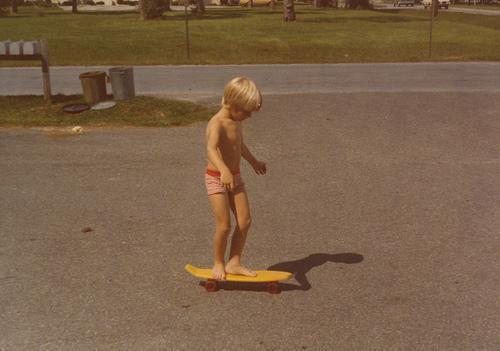How many people are there?
Give a very brief answer. 1. How many birds are looking at the camera?
Give a very brief answer. 0. 